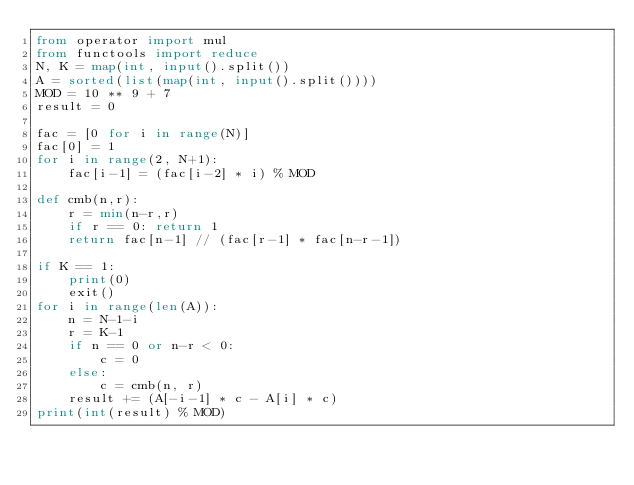<code> <loc_0><loc_0><loc_500><loc_500><_Python_>from operator import mul
from functools import reduce
N, K = map(int, input().split())
A = sorted(list(map(int, input().split())))
MOD = 10 ** 9 + 7
result = 0

fac = [0 for i in range(N)]
fac[0] = 1
for i in range(2, N+1):
    fac[i-1] = (fac[i-2] * i) % MOD

def cmb(n,r):
    r = min(n-r,r)
    if r == 0: return 1
    return fac[n-1] // (fac[r-1] * fac[n-r-1])

if K == 1:
    print(0)
    exit()
for i in range(len(A)):
    n = N-1-i
    r = K-1
    if n == 0 or n-r < 0:
        c = 0
    else:
        c = cmb(n, r)
    result += (A[-i-1] * c - A[i] * c)
print(int(result) % MOD)
</code> 